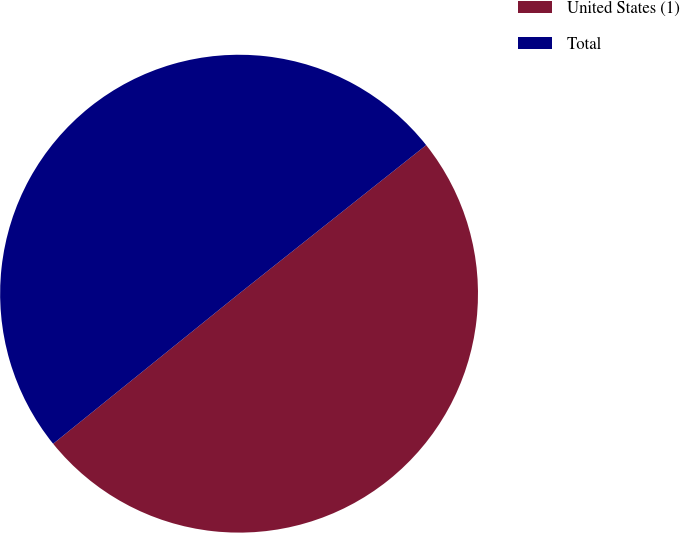Convert chart. <chart><loc_0><loc_0><loc_500><loc_500><pie_chart><fcel>United States (1)<fcel>Total<nl><fcel>49.87%<fcel>50.13%<nl></chart> 